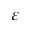Convert formula to latex. <formula><loc_0><loc_0><loc_500><loc_500>\varepsilon</formula> 